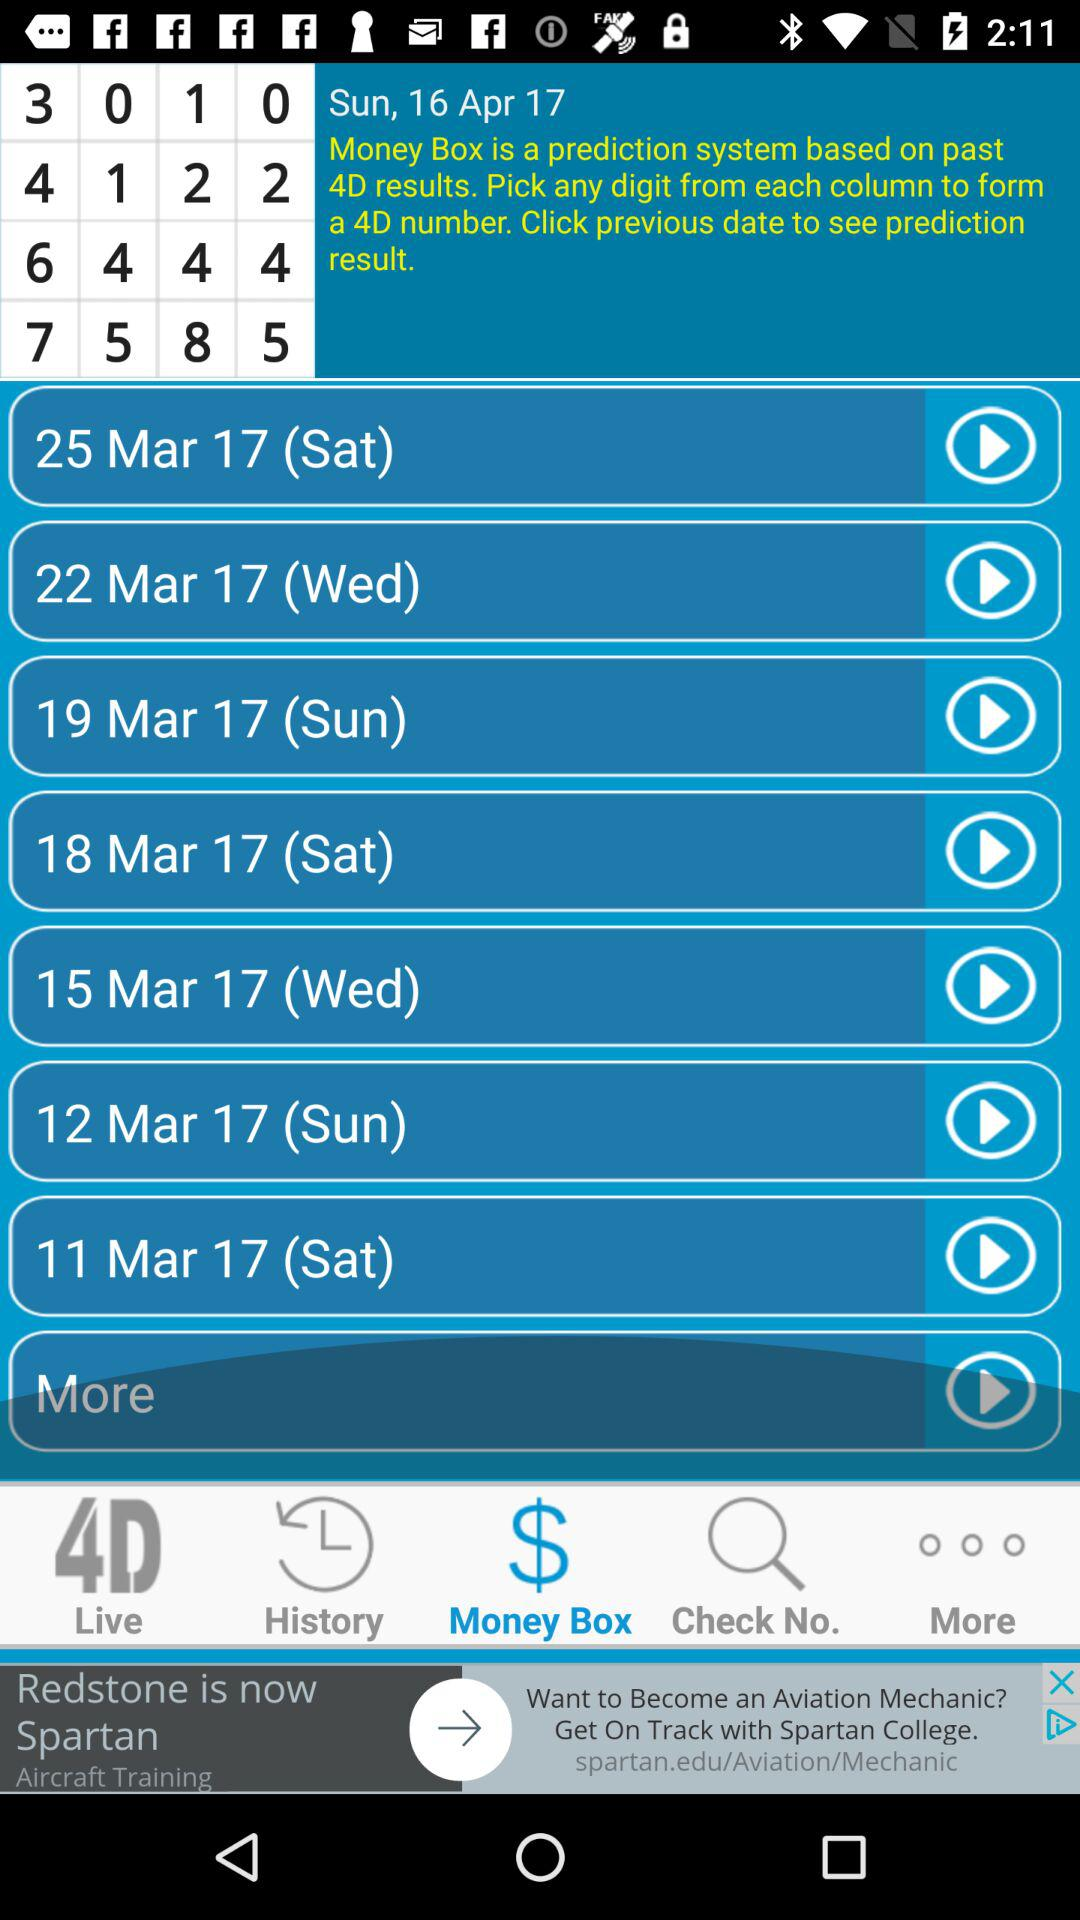What day is it on March 22, 2017? The day is Wednesday. 